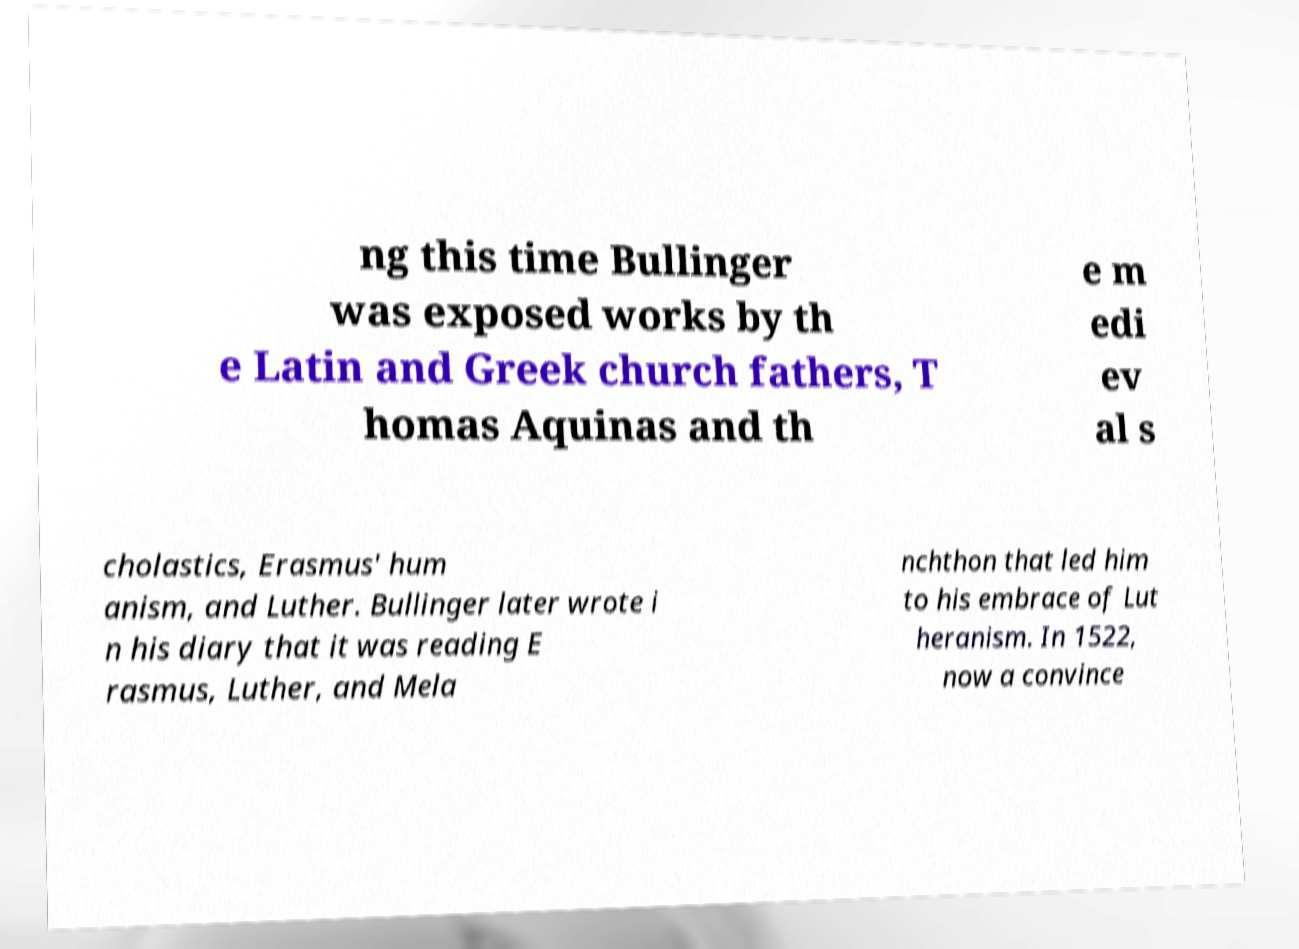There's text embedded in this image that I need extracted. Can you transcribe it verbatim? ng this time Bullinger was exposed works by th e Latin and Greek church fathers, T homas Aquinas and th e m edi ev al s cholastics, Erasmus' hum anism, and Luther. Bullinger later wrote i n his diary that it was reading E rasmus, Luther, and Mela nchthon that led him to his embrace of Lut heranism. In 1522, now a convince 